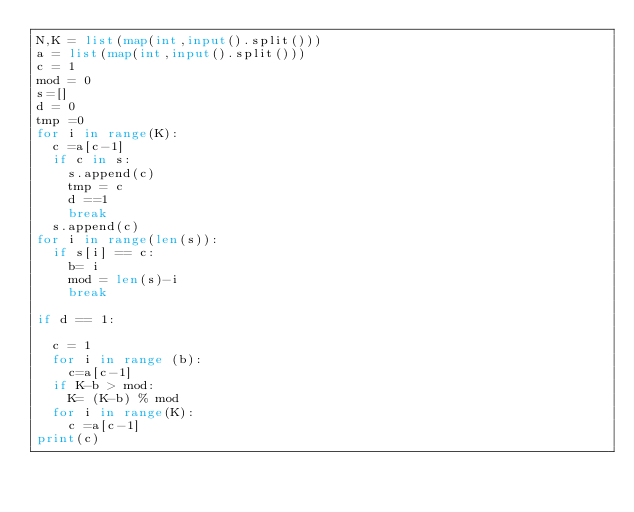Convert code to text. <code><loc_0><loc_0><loc_500><loc_500><_Python_>N,K = list(map(int,input().split()))
a = list(map(int,input().split()))
c = 1
mod = 0
s=[]
d = 0
tmp =0
for i in range(K):
	c =a[c-1]
	if c in s:
		s.append(c)
		tmp = c
		d ==1 
		break
	s.append(c)
for i in range(len(s)):
	if s[i] == c:
		b= i
		mod = len(s)-i
		break

if d == 1:

	c = 1
	for i in range (b):
		c=a[c-1]
	if K-b > mod:
		K= (K-b) % mod
	for i in range(K):
		c =a[c-1]
print(c)
</code> 